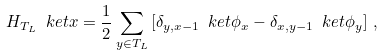Convert formula to latex. <formula><loc_0><loc_0><loc_500><loc_500>H _ { T _ { L } } \ k e t { x } = \frac { 1 } { 2 } \sum _ { y \in T _ { L } } \left [ \delta _ { y , x - 1 } \ k e t { \phi _ { x } } - \delta _ { x , y - 1 } \ k e t { \phi _ { y } } \right ] \, ,</formula> 